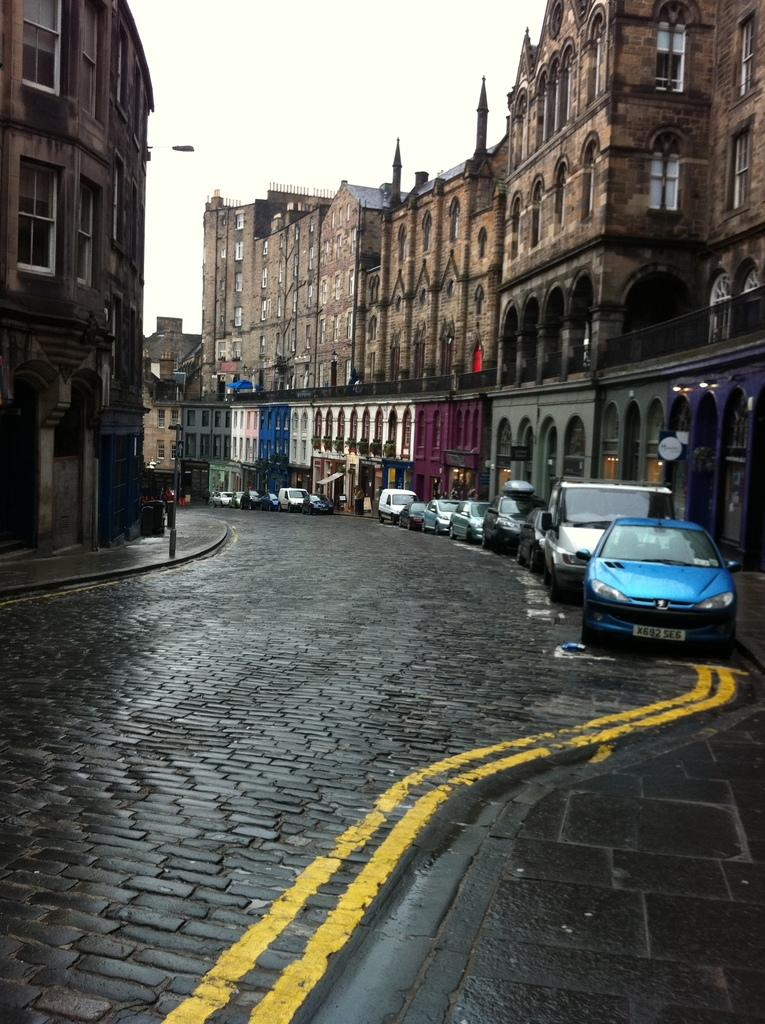<image>
Summarize the visual content of the image. Cars are parked along a curved road, a blue one with plate X692 SE6 in the front. 